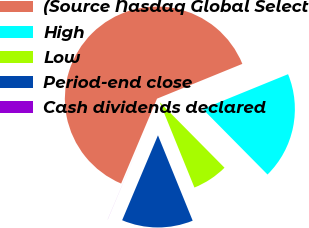<chart> <loc_0><loc_0><loc_500><loc_500><pie_chart><fcel>(Source Nasdaq Global Select<fcel>High<fcel>Low<fcel>Period-end close<fcel>Cash dividends declared<nl><fcel>62.47%<fcel>18.75%<fcel>6.26%<fcel>12.5%<fcel>0.01%<nl></chart> 